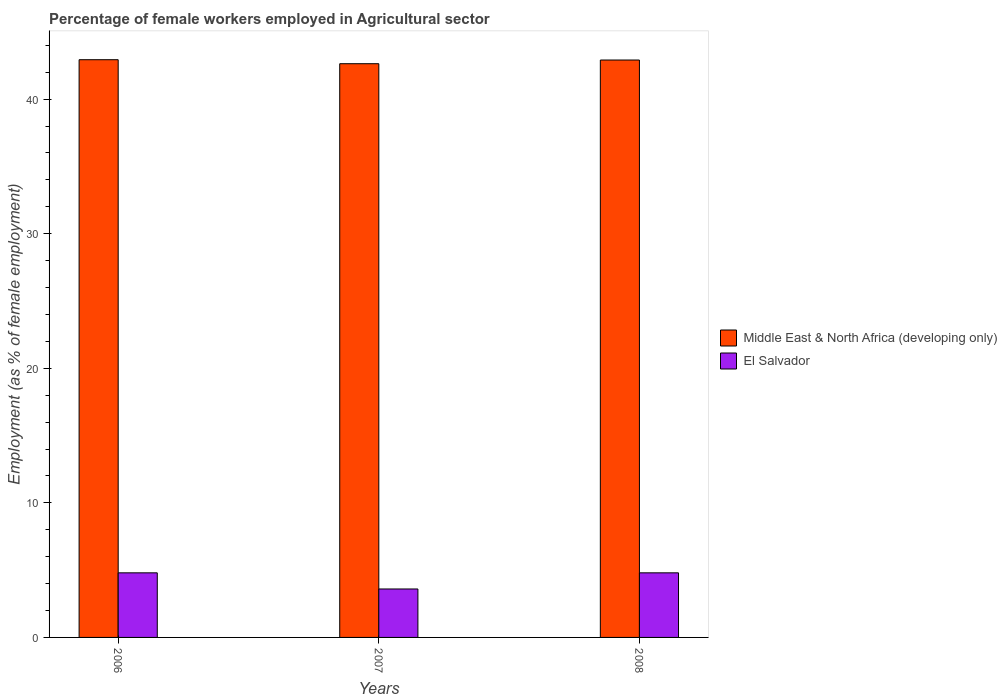How many groups of bars are there?
Offer a very short reply. 3. How many bars are there on the 1st tick from the right?
Make the answer very short. 2. What is the label of the 3rd group of bars from the left?
Offer a very short reply. 2008. In how many cases, is the number of bars for a given year not equal to the number of legend labels?
Keep it short and to the point. 0. What is the percentage of females employed in Agricultural sector in El Salvador in 2006?
Ensure brevity in your answer.  4.8. Across all years, what is the maximum percentage of females employed in Agricultural sector in Middle East & North Africa (developing only)?
Offer a very short reply. 42.93. Across all years, what is the minimum percentage of females employed in Agricultural sector in El Salvador?
Offer a very short reply. 3.6. In which year was the percentage of females employed in Agricultural sector in Middle East & North Africa (developing only) maximum?
Your response must be concise. 2006. What is the total percentage of females employed in Agricultural sector in El Salvador in the graph?
Offer a very short reply. 13.2. What is the difference between the percentage of females employed in Agricultural sector in El Salvador in 2006 and that in 2008?
Provide a succinct answer. 0. What is the difference between the percentage of females employed in Agricultural sector in El Salvador in 2008 and the percentage of females employed in Agricultural sector in Middle East & North Africa (developing only) in 2006?
Your response must be concise. -38.13. What is the average percentage of females employed in Agricultural sector in El Salvador per year?
Make the answer very short. 4.4. In the year 2006, what is the difference between the percentage of females employed in Agricultural sector in El Salvador and percentage of females employed in Agricultural sector in Middle East & North Africa (developing only)?
Your answer should be very brief. -38.13. In how many years, is the percentage of females employed in Agricultural sector in El Salvador greater than 28 %?
Give a very brief answer. 0. What is the ratio of the percentage of females employed in Agricultural sector in El Salvador in 2007 to that in 2008?
Make the answer very short. 0.75. Is the percentage of females employed in Agricultural sector in El Salvador in 2006 less than that in 2008?
Ensure brevity in your answer.  No. What is the difference between the highest and the lowest percentage of females employed in Agricultural sector in El Salvador?
Offer a terse response. 1.2. In how many years, is the percentage of females employed in Agricultural sector in Middle East & North Africa (developing only) greater than the average percentage of females employed in Agricultural sector in Middle East & North Africa (developing only) taken over all years?
Make the answer very short. 2. Is the sum of the percentage of females employed in Agricultural sector in Middle East & North Africa (developing only) in 2006 and 2008 greater than the maximum percentage of females employed in Agricultural sector in El Salvador across all years?
Your answer should be very brief. Yes. What does the 2nd bar from the left in 2008 represents?
Give a very brief answer. El Salvador. What does the 1st bar from the right in 2008 represents?
Your response must be concise. El Salvador. How many bars are there?
Provide a succinct answer. 6. Where does the legend appear in the graph?
Offer a very short reply. Center right. What is the title of the graph?
Provide a short and direct response. Percentage of female workers employed in Agricultural sector. Does "Central African Republic" appear as one of the legend labels in the graph?
Give a very brief answer. No. What is the label or title of the X-axis?
Keep it short and to the point. Years. What is the label or title of the Y-axis?
Provide a succinct answer. Employment (as % of female employment). What is the Employment (as % of female employment) of Middle East & North Africa (developing only) in 2006?
Offer a terse response. 42.93. What is the Employment (as % of female employment) of El Salvador in 2006?
Your response must be concise. 4.8. What is the Employment (as % of female employment) of Middle East & North Africa (developing only) in 2007?
Ensure brevity in your answer.  42.63. What is the Employment (as % of female employment) of El Salvador in 2007?
Offer a very short reply. 3.6. What is the Employment (as % of female employment) in Middle East & North Africa (developing only) in 2008?
Your answer should be very brief. 42.91. What is the Employment (as % of female employment) of El Salvador in 2008?
Provide a succinct answer. 4.8. Across all years, what is the maximum Employment (as % of female employment) of Middle East & North Africa (developing only)?
Make the answer very short. 42.93. Across all years, what is the maximum Employment (as % of female employment) of El Salvador?
Offer a terse response. 4.8. Across all years, what is the minimum Employment (as % of female employment) in Middle East & North Africa (developing only)?
Give a very brief answer. 42.63. Across all years, what is the minimum Employment (as % of female employment) in El Salvador?
Ensure brevity in your answer.  3.6. What is the total Employment (as % of female employment) in Middle East & North Africa (developing only) in the graph?
Make the answer very short. 128.47. What is the total Employment (as % of female employment) of El Salvador in the graph?
Offer a terse response. 13.2. What is the difference between the Employment (as % of female employment) of Middle East & North Africa (developing only) in 2006 and that in 2007?
Offer a very short reply. 0.3. What is the difference between the Employment (as % of female employment) of Middle East & North Africa (developing only) in 2006 and that in 2008?
Your answer should be compact. 0.02. What is the difference between the Employment (as % of female employment) of El Salvador in 2006 and that in 2008?
Ensure brevity in your answer.  0. What is the difference between the Employment (as % of female employment) in Middle East & North Africa (developing only) in 2007 and that in 2008?
Make the answer very short. -0.27. What is the difference between the Employment (as % of female employment) in Middle East & North Africa (developing only) in 2006 and the Employment (as % of female employment) in El Salvador in 2007?
Provide a short and direct response. 39.33. What is the difference between the Employment (as % of female employment) of Middle East & North Africa (developing only) in 2006 and the Employment (as % of female employment) of El Salvador in 2008?
Your answer should be very brief. 38.13. What is the difference between the Employment (as % of female employment) in Middle East & North Africa (developing only) in 2007 and the Employment (as % of female employment) in El Salvador in 2008?
Ensure brevity in your answer.  37.83. What is the average Employment (as % of female employment) in Middle East & North Africa (developing only) per year?
Your answer should be very brief. 42.82. In the year 2006, what is the difference between the Employment (as % of female employment) in Middle East & North Africa (developing only) and Employment (as % of female employment) in El Salvador?
Keep it short and to the point. 38.13. In the year 2007, what is the difference between the Employment (as % of female employment) in Middle East & North Africa (developing only) and Employment (as % of female employment) in El Salvador?
Offer a terse response. 39.03. In the year 2008, what is the difference between the Employment (as % of female employment) in Middle East & North Africa (developing only) and Employment (as % of female employment) in El Salvador?
Keep it short and to the point. 38.11. What is the ratio of the Employment (as % of female employment) in Middle East & North Africa (developing only) in 2006 to that in 2007?
Ensure brevity in your answer.  1.01. What is the ratio of the Employment (as % of female employment) of El Salvador in 2006 to that in 2007?
Give a very brief answer. 1.33. What is the difference between the highest and the second highest Employment (as % of female employment) of Middle East & North Africa (developing only)?
Your answer should be compact. 0.02. What is the difference between the highest and the lowest Employment (as % of female employment) of Middle East & North Africa (developing only)?
Give a very brief answer. 0.3. What is the difference between the highest and the lowest Employment (as % of female employment) of El Salvador?
Your answer should be very brief. 1.2. 